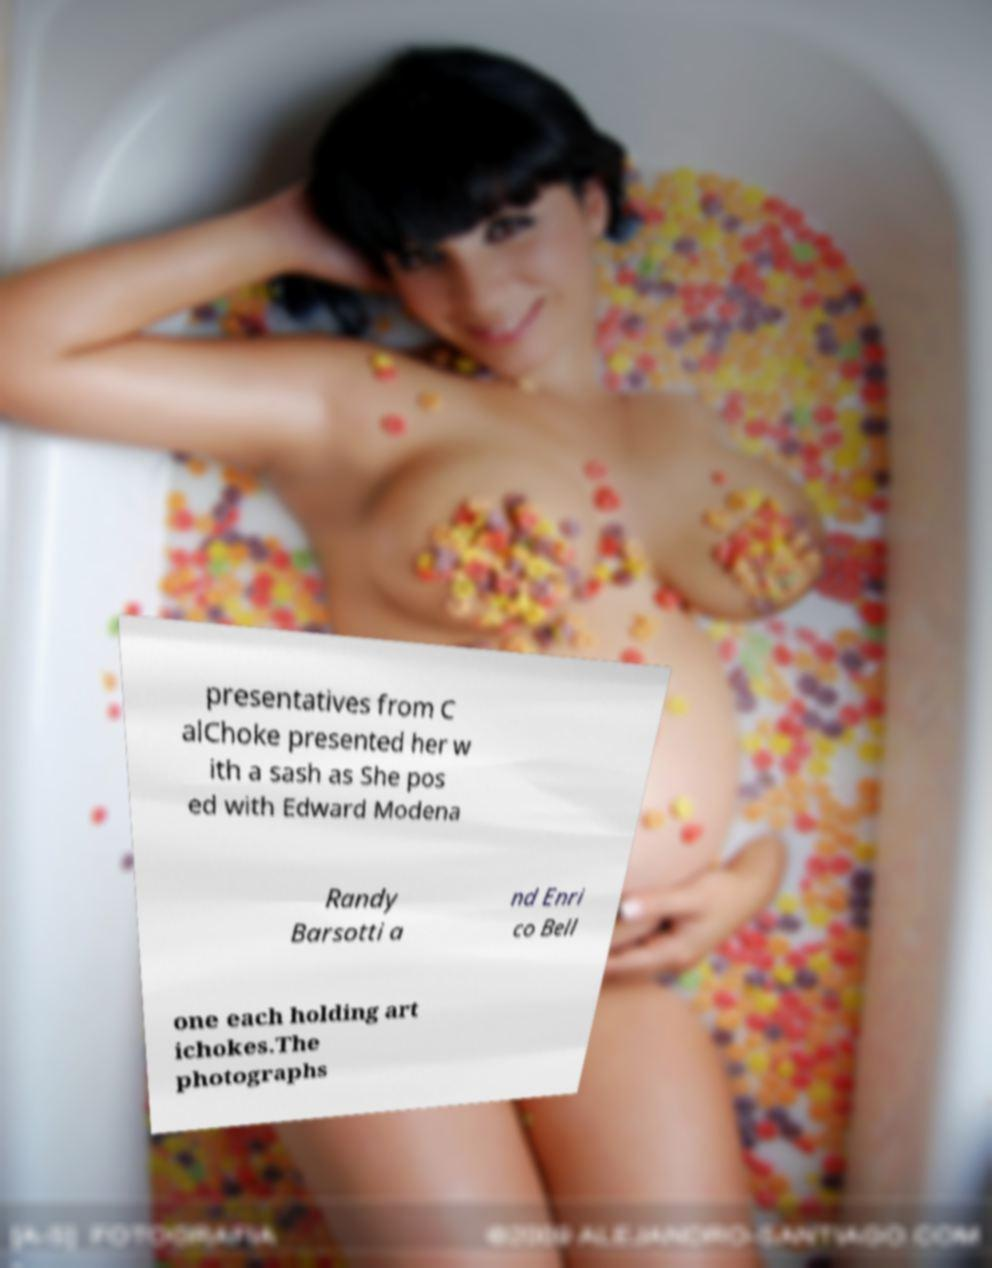Can you accurately transcribe the text from the provided image for me? presentatives from C alChoke presented her w ith a sash as She pos ed with Edward Modena Randy Barsotti a nd Enri co Bell one each holding art ichokes.The photographs 